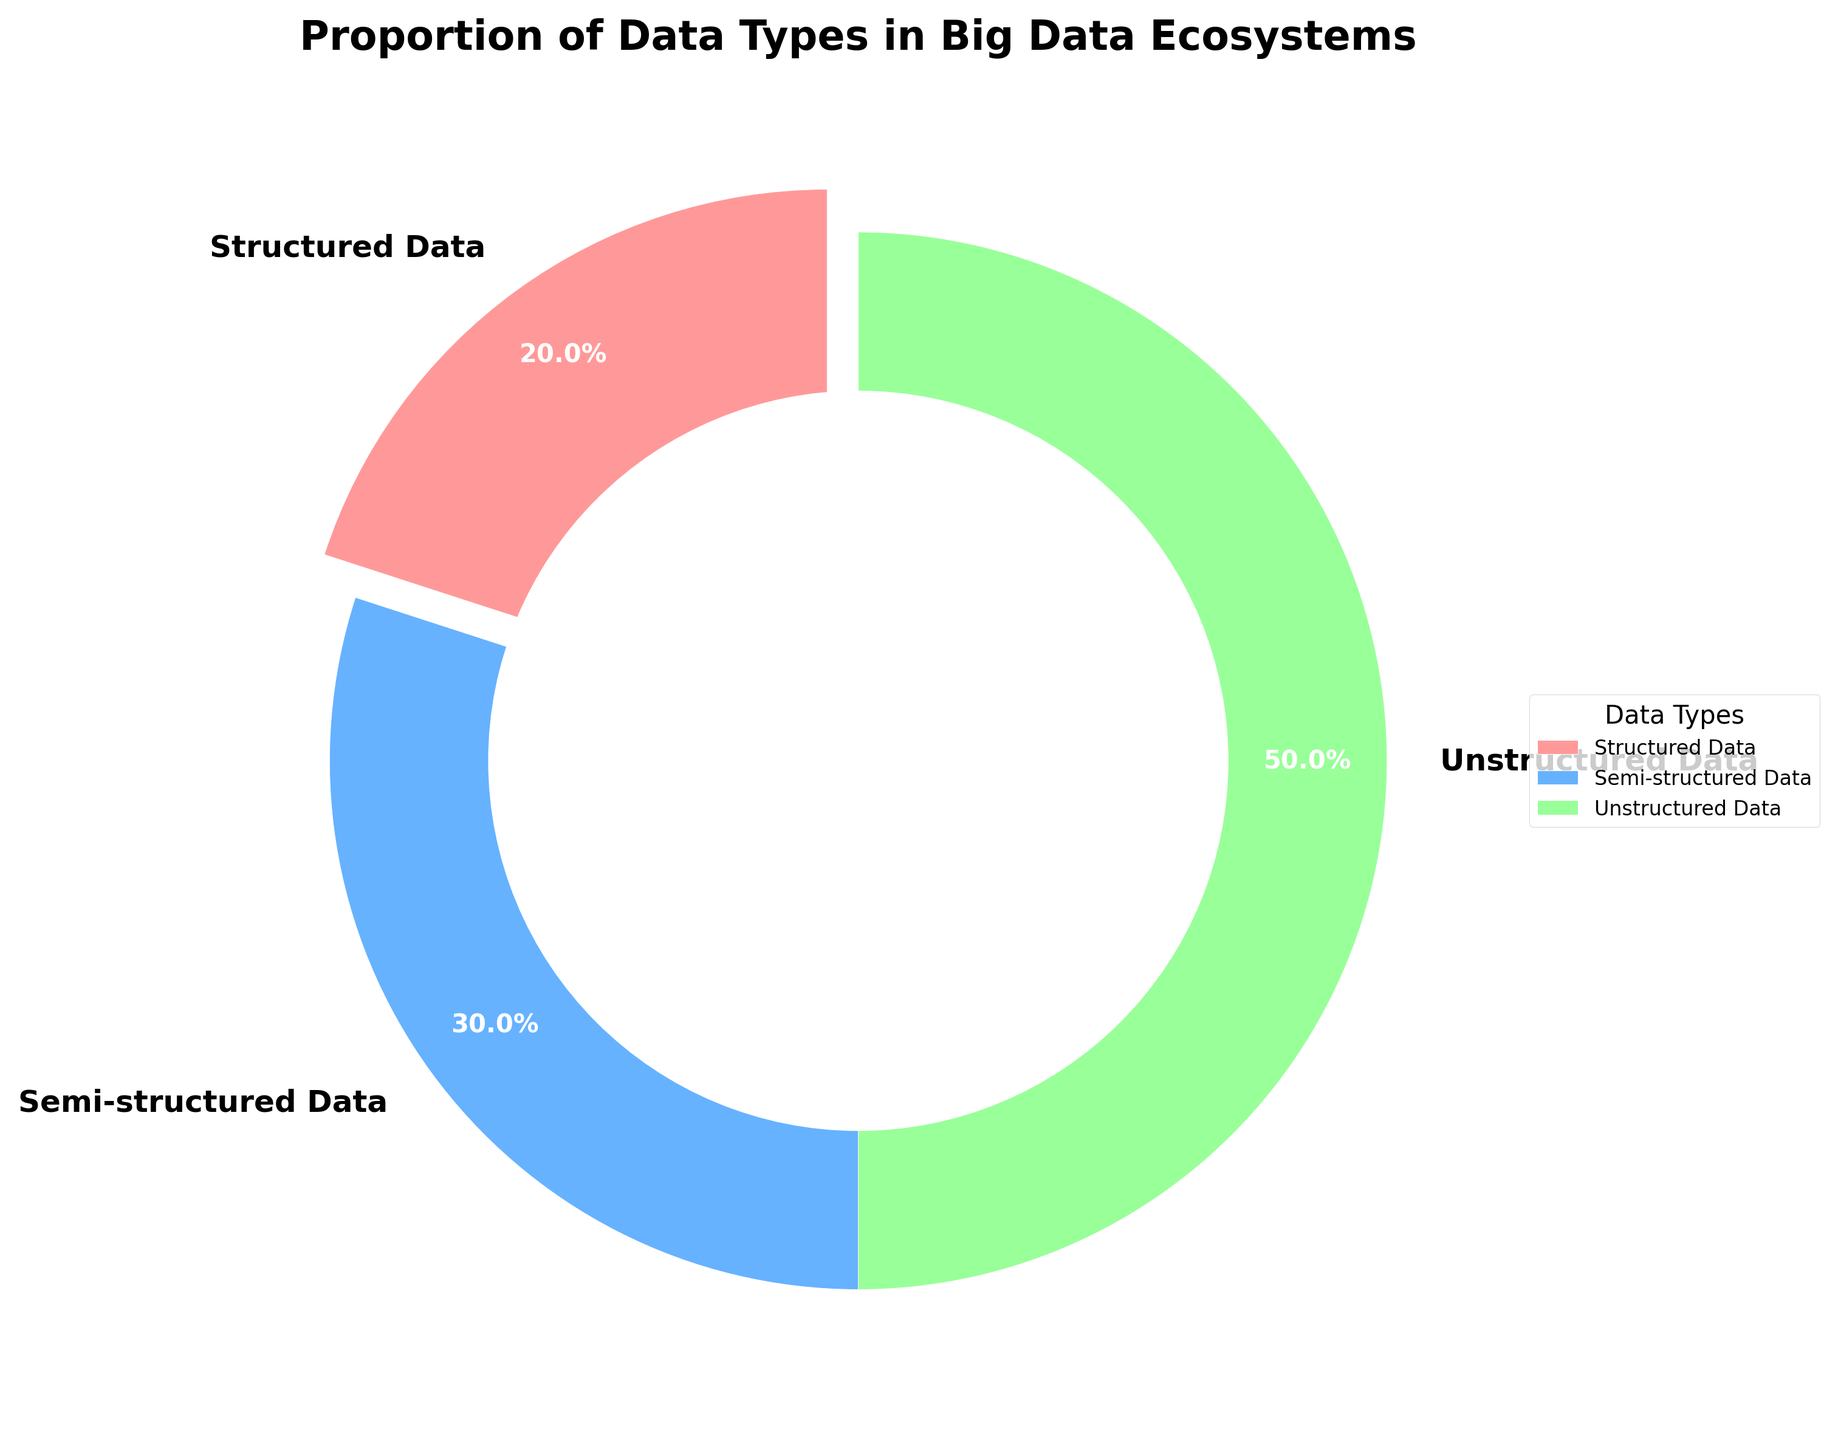Which data type has the largest proportion? The data type with the largest proportion is the one with the highest percentage. By looking at the pie chart, we see that Unstructured Data has 50%, which is the highest.
Answer: Unstructured Data What is the sum of the proportions of structured and semi-structured data? Add the percentages of Structured Data (20%) and Semi-structured Data (30%). So, 20% + 30% = 50%.
Answer: 50% How much larger is the proportion of unstructured data compared to structured data? Subtract the percentage of Structured Data (20%) from the percentage of Unstructured Data (50%). So, 50% - 20% = 30%.
Answer: 30% What is the average proportion of all data types? Add the percentages of all data types and divide by the number of data types. So, (20% + 30% + 50%)/3 = 33.33%
Answer: 33.33% Which data type has the smallest proportion? The data type with the smallest proportion is the one with the lowest percentage. From the pie chart, Structured Data has 20%, which is the lowest.
Answer: Structured Data Is the proportion of semi-structured data greater than structured data? Compare the percentage of Semi-structured Data (30%) with Structured Data (20%). Since 30% is greater than 20%, the answer is yes.
Answer: Yes What proportion does the green segment represent? The green segment in the pie chart represents Unstructured Data, which has a percentage of 50%.
Answer: 50% What is the difference between the proportions of semi-structured and unstructured data? Subtract the percentage of Semi-structured Data (30%) from the percentage of Unstructured Data (50%). So, 50% - 30% = 20%.
Answer: 20% How many data types are represented in the pie chart? Count the number of segments in the pie chart. There are three segments, hence three data types are represented.
Answer: 3 What visual attribute distinguishes the segment representing structured data? The segment representing Structured Data is distinguished by its position and, specifically, it is slightly separated from the center (exploded).
Answer: It is exploded 